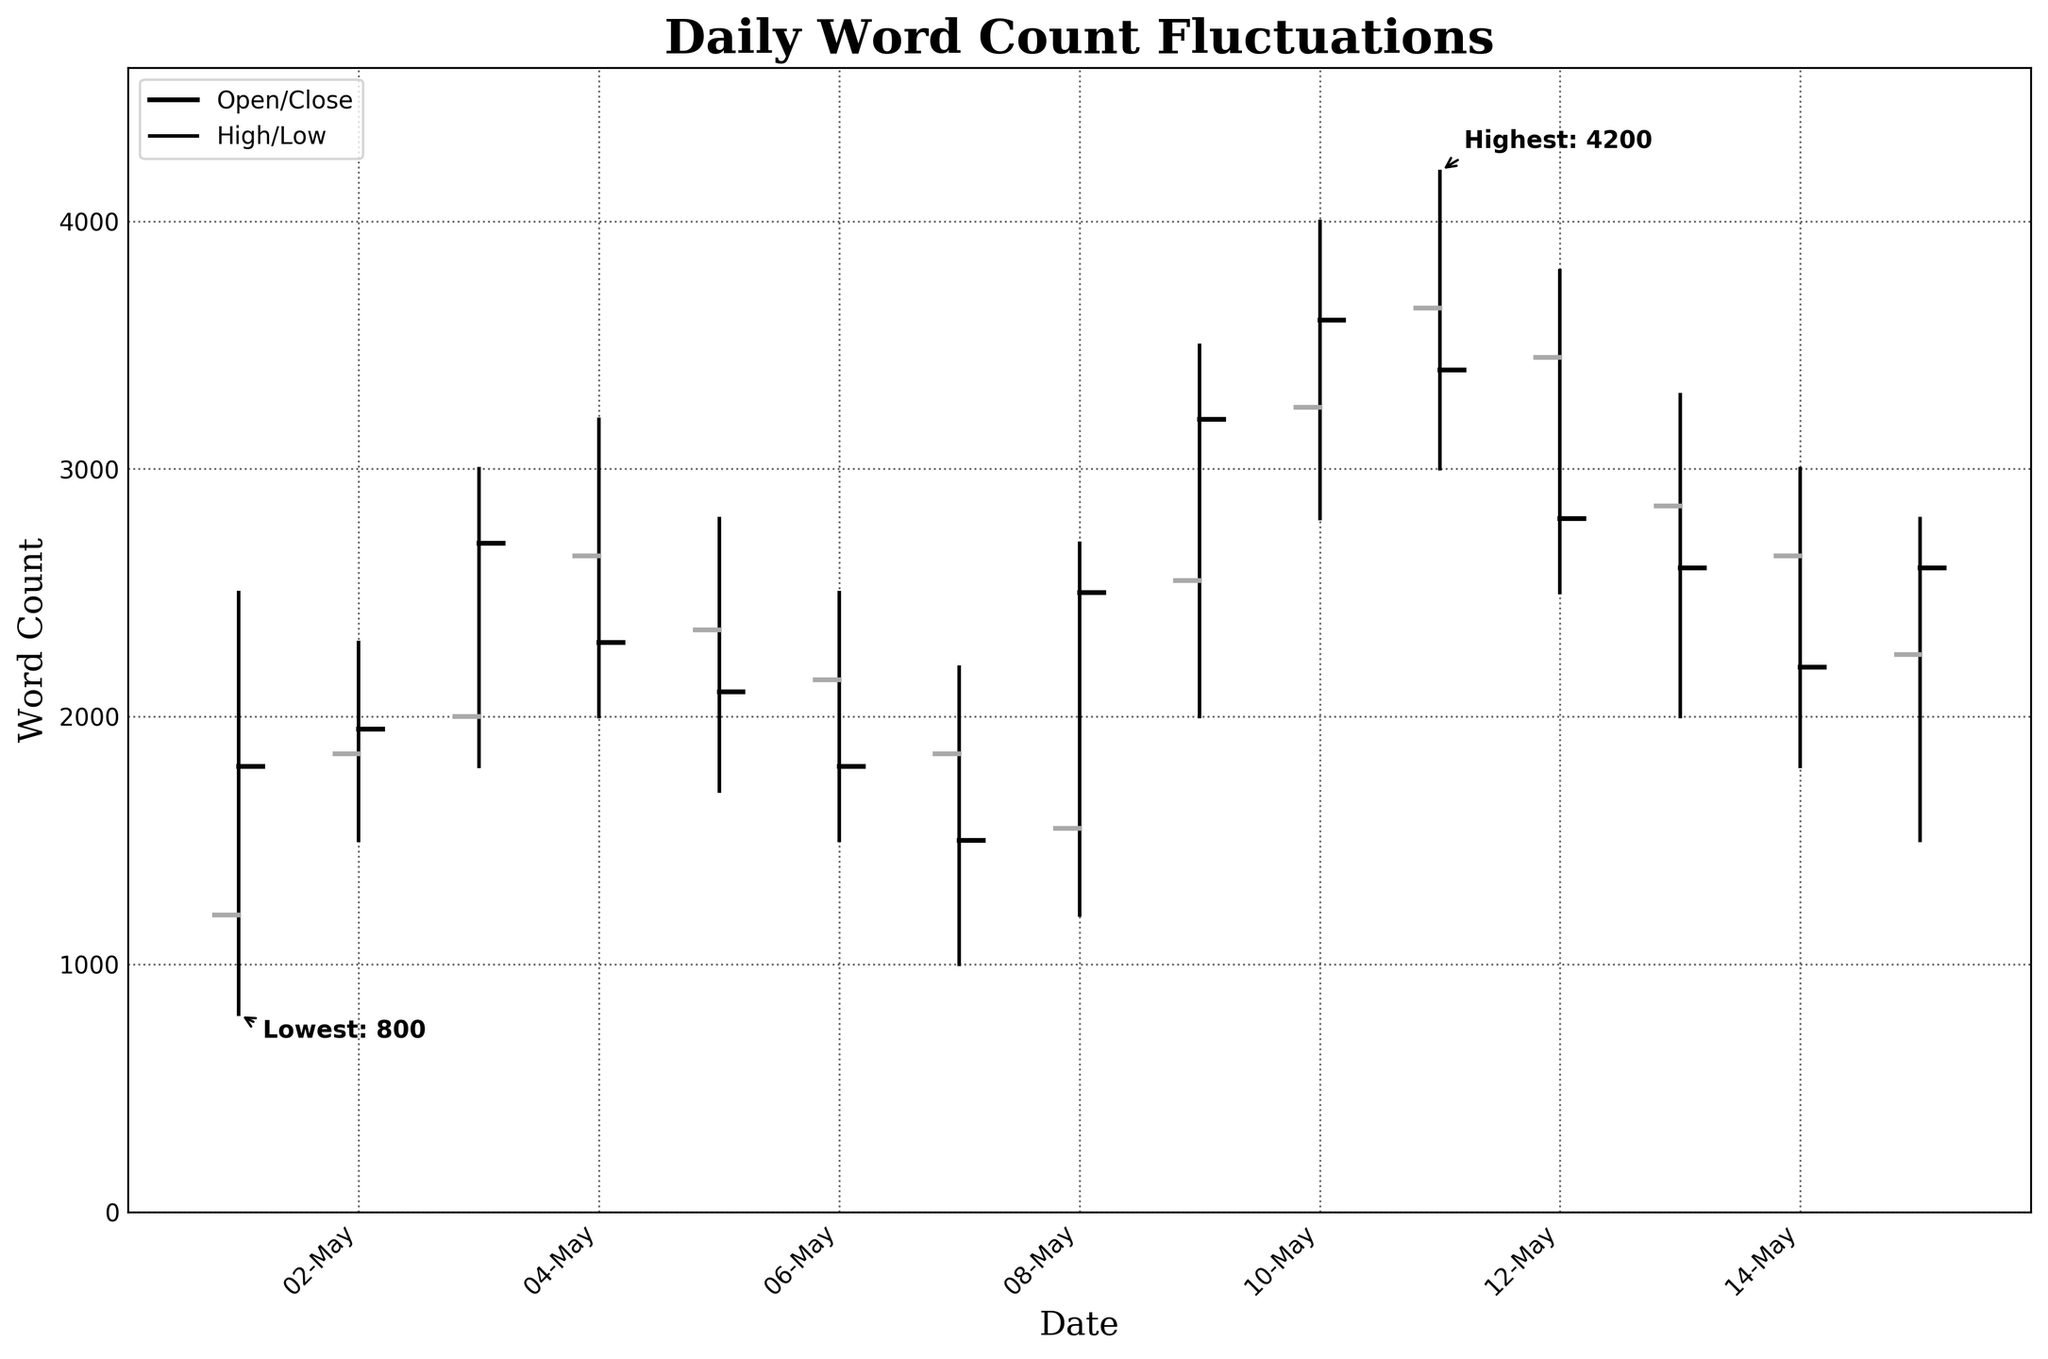What is the title of the figure? The title is usually displayed at the top of the figure. By looking at the top, you can see the title "Daily Word Count Fluctuations".
Answer: Daily Word Count Fluctuations How many days of data are shown in the figure? By counting the number of unique date points along the x-axis, we see that there are 15 data points, indicating 15 days of data.
Answer: 15 What is the highest word count recorded, and on which date did it occur? The highest point on the y-axis represents the maximum word count. The annotation indicates that the highest word count is 4200, which occurred on 2023-05-11.
Answer: 4200 on 2023-05-11 What is the lowest word count recorded, and on which date did it occur? The lowest point on the y-axis represents the minimum word count. The annotation indicates that the lowest word count is 800, which occurred on 2023-05-01.
Answer: 800 on 2023-05-01 On which date did the word count close equal to the word count it opened with? To find this, we need to look at the dates where the horizontal lines on either side of the vertical line are at the same y-axis level. For May 1st (2023-05-01), the opening and closing word counts are both 1800.
Answer: 2023-05-01 What is the average closing word count over the 15-day period? Summing all the closing word counts (1800+1950+2700+2300+2100+1800+1500+2500+3200+3600+3400+2800+2600+2200+2600) gives 39650. Dividing by 15 gives the average closing word count as 39650/15 = 2643.33.
Answer: 2643.33 Which date had the greatest fluctuation in word count within a single day? The fluctuation can be calculated by finding the difference between the High and Low values for each date. The greatest fluctuation is 4200-3000=1200, which occurred on 2023-05-11.
Answer: 2023-05-11 Between which two consecutive days was the word count change the most significant? The significant change can be found by calculating the absolute difference in the closing word count from one day to the next. The largest difference is between May 13 (2600) and May 14 (2200), which is abs(2600-2200) = 400.
Answer: 2023-05-13 to 2023-05-14 What is the trend of word count over the first five days of the month? To identify the trend, compare the general direction of the closing values on the first five days. From 1800 to 1950 to 2700 to 2300 to 2100, there was a general increase initially, followed by a decline.
Answer: Increasing then decreasing On which date is the opening word count closest to the closing word count of the previous day? Compare each day's opening word count with the previous day's closing word count. On May 8 (2023-05-08), the opening word count of 1550 matches the closing word count of 1500 on May 7 (2023-05-07), closely with a difference of 50.
Answer: 2023-05-08 with 2023-05-07 